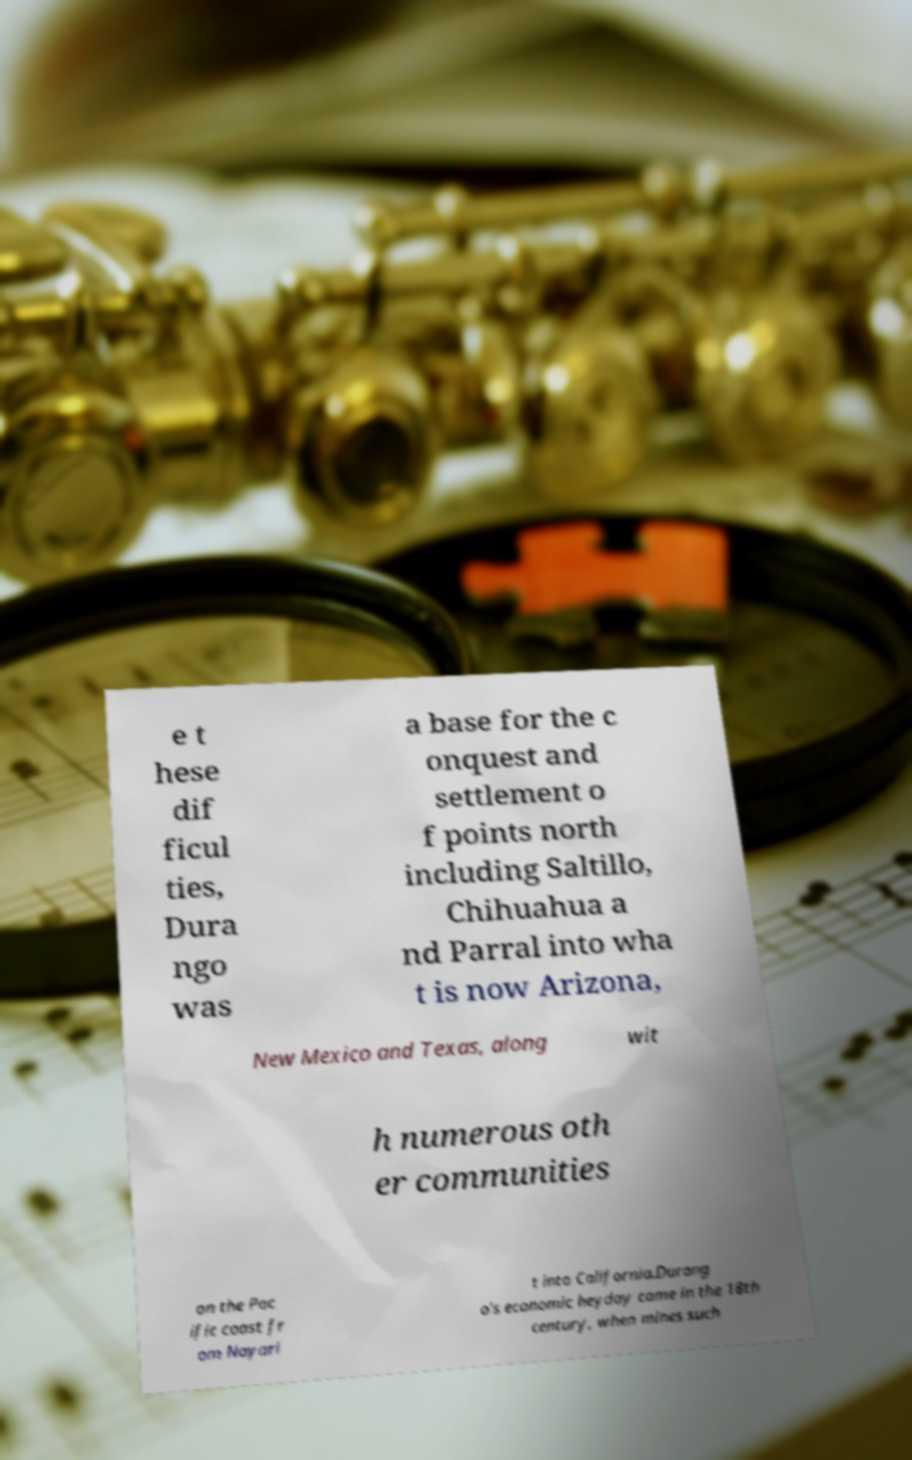Please identify and transcribe the text found in this image. e t hese dif ficul ties, Dura ngo was a base for the c onquest and settlement o f points north including Saltillo, Chihuahua a nd Parral into wha t is now Arizona, New Mexico and Texas, along wit h numerous oth er communities on the Pac ific coast fr om Nayari t into California.Durang o's economic heyday came in the 18th century, when mines such 